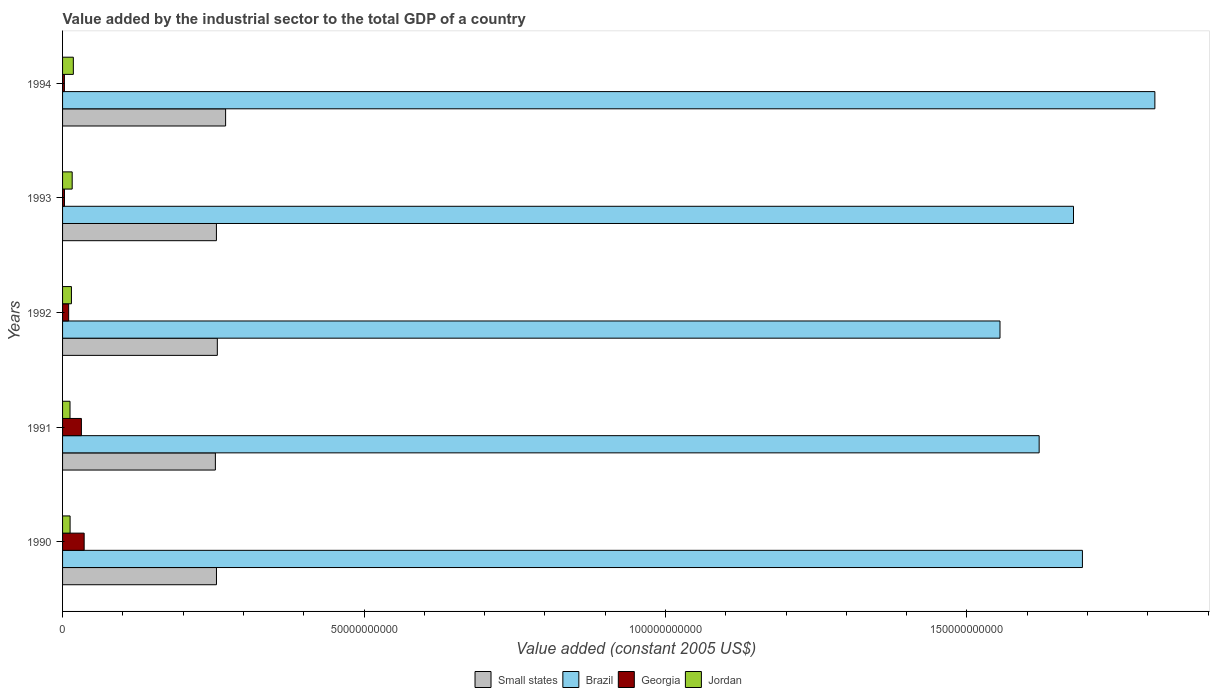How many different coloured bars are there?
Provide a short and direct response. 4. Are the number of bars on each tick of the Y-axis equal?
Keep it short and to the point. Yes. How many bars are there on the 1st tick from the bottom?
Provide a succinct answer. 4. What is the label of the 4th group of bars from the top?
Your response must be concise. 1991. What is the value added by the industrial sector in Georgia in 1992?
Your response must be concise. 1.01e+09. Across all years, what is the maximum value added by the industrial sector in Small states?
Your answer should be very brief. 2.70e+1. Across all years, what is the minimum value added by the industrial sector in Small states?
Provide a succinct answer. 2.53e+1. In which year was the value added by the industrial sector in Small states maximum?
Keep it short and to the point. 1994. What is the total value added by the industrial sector in Brazil in the graph?
Keep it short and to the point. 8.35e+11. What is the difference between the value added by the industrial sector in Jordan in 1990 and that in 1991?
Provide a succinct answer. 1.42e+07. What is the difference between the value added by the industrial sector in Georgia in 1992 and the value added by the industrial sector in Jordan in 1994?
Offer a terse response. -7.79e+08. What is the average value added by the industrial sector in Brazil per year?
Give a very brief answer. 1.67e+11. In the year 1992, what is the difference between the value added by the industrial sector in Jordan and value added by the industrial sector in Brazil?
Your answer should be very brief. -1.54e+11. In how many years, is the value added by the industrial sector in Small states greater than 10000000000 US$?
Give a very brief answer. 5. What is the ratio of the value added by the industrial sector in Small states in 1991 to that in 1992?
Give a very brief answer. 0.99. Is the difference between the value added by the industrial sector in Jordan in 1990 and 1991 greater than the difference between the value added by the industrial sector in Brazil in 1990 and 1991?
Provide a succinct answer. No. What is the difference between the highest and the second highest value added by the industrial sector in Jordan?
Make the answer very short. 1.92e+08. What is the difference between the highest and the lowest value added by the industrial sector in Georgia?
Keep it short and to the point. 3.28e+09. Is the sum of the value added by the industrial sector in Jordan in 1993 and 1994 greater than the maximum value added by the industrial sector in Small states across all years?
Your answer should be very brief. No. Is it the case that in every year, the sum of the value added by the industrial sector in Small states and value added by the industrial sector in Georgia is greater than the sum of value added by the industrial sector in Brazil and value added by the industrial sector in Jordan?
Offer a terse response. No. What does the 2nd bar from the top in 1990 represents?
Provide a succinct answer. Georgia. Is it the case that in every year, the sum of the value added by the industrial sector in Brazil and value added by the industrial sector in Small states is greater than the value added by the industrial sector in Jordan?
Your answer should be compact. Yes. Are all the bars in the graph horizontal?
Keep it short and to the point. Yes. Are the values on the major ticks of X-axis written in scientific E-notation?
Keep it short and to the point. No. Does the graph contain grids?
Keep it short and to the point. No. Where does the legend appear in the graph?
Provide a short and direct response. Bottom center. How many legend labels are there?
Provide a succinct answer. 4. How are the legend labels stacked?
Provide a succinct answer. Horizontal. What is the title of the graph?
Offer a terse response. Value added by the industrial sector to the total GDP of a country. What is the label or title of the X-axis?
Offer a very short reply. Value added (constant 2005 US$). What is the label or title of the Y-axis?
Your response must be concise. Years. What is the Value added (constant 2005 US$) of Small states in 1990?
Give a very brief answer. 2.55e+1. What is the Value added (constant 2005 US$) of Brazil in 1990?
Make the answer very short. 1.69e+11. What is the Value added (constant 2005 US$) of Georgia in 1990?
Your response must be concise. 3.58e+09. What is the Value added (constant 2005 US$) of Jordan in 1990?
Ensure brevity in your answer.  1.25e+09. What is the Value added (constant 2005 US$) in Small states in 1991?
Your response must be concise. 2.53e+1. What is the Value added (constant 2005 US$) of Brazil in 1991?
Provide a short and direct response. 1.62e+11. What is the Value added (constant 2005 US$) in Georgia in 1991?
Provide a short and direct response. 3.12e+09. What is the Value added (constant 2005 US$) in Jordan in 1991?
Keep it short and to the point. 1.23e+09. What is the Value added (constant 2005 US$) of Small states in 1992?
Your answer should be compact. 2.57e+1. What is the Value added (constant 2005 US$) in Brazil in 1992?
Make the answer very short. 1.55e+11. What is the Value added (constant 2005 US$) of Georgia in 1992?
Make the answer very short. 1.01e+09. What is the Value added (constant 2005 US$) of Jordan in 1992?
Offer a terse response. 1.47e+09. What is the Value added (constant 2005 US$) of Small states in 1993?
Ensure brevity in your answer.  2.55e+1. What is the Value added (constant 2005 US$) of Brazil in 1993?
Ensure brevity in your answer.  1.68e+11. What is the Value added (constant 2005 US$) in Georgia in 1993?
Your response must be concise. 3.16e+08. What is the Value added (constant 2005 US$) in Jordan in 1993?
Your response must be concise. 1.60e+09. What is the Value added (constant 2005 US$) of Small states in 1994?
Your response must be concise. 2.70e+1. What is the Value added (constant 2005 US$) of Brazil in 1994?
Make the answer very short. 1.81e+11. What is the Value added (constant 2005 US$) in Georgia in 1994?
Keep it short and to the point. 3.04e+08. What is the Value added (constant 2005 US$) in Jordan in 1994?
Offer a very short reply. 1.79e+09. Across all years, what is the maximum Value added (constant 2005 US$) in Small states?
Offer a terse response. 2.70e+1. Across all years, what is the maximum Value added (constant 2005 US$) of Brazil?
Offer a very short reply. 1.81e+11. Across all years, what is the maximum Value added (constant 2005 US$) of Georgia?
Provide a short and direct response. 3.58e+09. Across all years, what is the maximum Value added (constant 2005 US$) of Jordan?
Your response must be concise. 1.79e+09. Across all years, what is the minimum Value added (constant 2005 US$) of Small states?
Provide a short and direct response. 2.53e+1. Across all years, what is the minimum Value added (constant 2005 US$) of Brazil?
Make the answer very short. 1.55e+11. Across all years, what is the minimum Value added (constant 2005 US$) of Georgia?
Make the answer very short. 3.04e+08. Across all years, what is the minimum Value added (constant 2005 US$) in Jordan?
Offer a very short reply. 1.23e+09. What is the total Value added (constant 2005 US$) of Small states in the graph?
Provide a succinct answer. 1.29e+11. What is the total Value added (constant 2005 US$) of Brazil in the graph?
Keep it short and to the point. 8.35e+11. What is the total Value added (constant 2005 US$) in Georgia in the graph?
Offer a very short reply. 8.33e+09. What is the total Value added (constant 2005 US$) in Jordan in the graph?
Your answer should be very brief. 7.34e+09. What is the difference between the Value added (constant 2005 US$) of Small states in 1990 and that in 1991?
Your response must be concise. 1.81e+08. What is the difference between the Value added (constant 2005 US$) in Brazil in 1990 and that in 1991?
Provide a short and direct response. 7.18e+09. What is the difference between the Value added (constant 2005 US$) in Georgia in 1990 and that in 1991?
Offer a very short reply. 4.58e+08. What is the difference between the Value added (constant 2005 US$) in Jordan in 1990 and that in 1991?
Offer a very short reply. 1.42e+07. What is the difference between the Value added (constant 2005 US$) in Small states in 1990 and that in 1992?
Your response must be concise. -1.41e+08. What is the difference between the Value added (constant 2005 US$) in Brazil in 1990 and that in 1992?
Your response must be concise. 1.37e+1. What is the difference between the Value added (constant 2005 US$) in Georgia in 1990 and that in 1992?
Offer a terse response. 2.57e+09. What is the difference between the Value added (constant 2005 US$) in Jordan in 1990 and that in 1992?
Offer a terse response. -2.22e+08. What is the difference between the Value added (constant 2005 US$) of Small states in 1990 and that in 1993?
Offer a terse response. 9.01e+06. What is the difference between the Value added (constant 2005 US$) in Brazil in 1990 and that in 1993?
Your answer should be compact. 1.48e+09. What is the difference between the Value added (constant 2005 US$) of Georgia in 1990 and that in 1993?
Provide a succinct answer. 3.27e+09. What is the difference between the Value added (constant 2005 US$) in Jordan in 1990 and that in 1993?
Your answer should be compact. -3.48e+08. What is the difference between the Value added (constant 2005 US$) in Small states in 1990 and that in 1994?
Your answer should be very brief. -1.52e+09. What is the difference between the Value added (constant 2005 US$) in Brazil in 1990 and that in 1994?
Your answer should be very brief. -1.20e+1. What is the difference between the Value added (constant 2005 US$) in Georgia in 1990 and that in 1994?
Your response must be concise. 3.28e+09. What is the difference between the Value added (constant 2005 US$) in Jordan in 1990 and that in 1994?
Offer a very short reply. -5.40e+08. What is the difference between the Value added (constant 2005 US$) in Small states in 1991 and that in 1992?
Give a very brief answer. -3.23e+08. What is the difference between the Value added (constant 2005 US$) in Brazil in 1991 and that in 1992?
Offer a very short reply. 6.49e+09. What is the difference between the Value added (constant 2005 US$) of Georgia in 1991 and that in 1992?
Your response must be concise. 2.11e+09. What is the difference between the Value added (constant 2005 US$) in Jordan in 1991 and that in 1992?
Your answer should be compact. -2.37e+08. What is the difference between the Value added (constant 2005 US$) of Small states in 1991 and that in 1993?
Provide a short and direct response. -1.72e+08. What is the difference between the Value added (constant 2005 US$) in Brazil in 1991 and that in 1993?
Offer a terse response. -5.70e+09. What is the difference between the Value added (constant 2005 US$) of Georgia in 1991 and that in 1993?
Offer a terse response. 2.81e+09. What is the difference between the Value added (constant 2005 US$) of Jordan in 1991 and that in 1993?
Offer a terse response. -3.62e+08. What is the difference between the Value added (constant 2005 US$) of Small states in 1991 and that in 1994?
Ensure brevity in your answer.  -1.70e+09. What is the difference between the Value added (constant 2005 US$) in Brazil in 1991 and that in 1994?
Give a very brief answer. -1.92e+1. What is the difference between the Value added (constant 2005 US$) of Georgia in 1991 and that in 1994?
Give a very brief answer. 2.82e+09. What is the difference between the Value added (constant 2005 US$) in Jordan in 1991 and that in 1994?
Offer a terse response. -5.54e+08. What is the difference between the Value added (constant 2005 US$) of Small states in 1992 and that in 1993?
Keep it short and to the point. 1.50e+08. What is the difference between the Value added (constant 2005 US$) in Brazil in 1992 and that in 1993?
Ensure brevity in your answer.  -1.22e+1. What is the difference between the Value added (constant 2005 US$) in Georgia in 1992 and that in 1993?
Your response must be concise. 6.94e+08. What is the difference between the Value added (constant 2005 US$) of Jordan in 1992 and that in 1993?
Provide a short and direct response. -1.25e+08. What is the difference between the Value added (constant 2005 US$) in Small states in 1992 and that in 1994?
Your answer should be very brief. -1.37e+09. What is the difference between the Value added (constant 2005 US$) of Brazil in 1992 and that in 1994?
Your response must be concise. -2.57e+1. What is the difference between the Value added (constant 2005 US$) in Georgia in 1992 and that in 1994?
Offer a terse response. 7.05e+08. What is the difference between the Value added (constant 2005 US$) of Jordan in 1992 and that in 1994?
Ensure brevity in your answer.  -3.17e+08. What is the difference between the Value added (constant 2005 US$) of Small states in 1993 and that in 1994?
Offer a very short reply. -1.52e+09. What is the difference between the Value added (constant 2005 US$) in Brazil in 1993 and that in 1994?
Provide a succinct answer. -1.35e+1. What is the difference between the Value added (constant 2005 US$) in Georgia in 1993 and that in 1994?
Your answer should be very brief. 1.17e+07. What is the difference between the Value added (constant 2005 US$) in Jordan in 1993 and that in 1994?
Offer a very short reply. -1.92e+08. What is the difference between the Value added (constant 2005 US$) in Small states in 1990 and the Value added (constant 2005 US$) in Brazil in 1991?
Offer a very short reply. -1.36e+11. What is the difference between the Value added (constant 2005 US$) of Small states in 1990 and the Value added (constant 2005 US$) of Georgia in 1991?
Your answer should be very brief. 2.24e+1. What is the difference between the Value added (constant 2005 US$) in Small states in 1990 and the Value added (constant 2005 US$) in Jordan in 1991?
Your answer should be very brief. 2.43e+1. What is the difference between the Value added (constant 2005 US$) of Brazil in 1990 and the Value added (constant 2005 US$) of Georgia in 1991?
Offer a terse response. 1.66e+11. What is the difference between the Value added (constant 2005 US$) in Brazil in 1990 and the Value added (constant 2005 US$) in Jordan in 1991?
Your answer should be very brief. 1.68e+11. What is the difference between the Value added (constant 2005 US$) in Georgia in 1990 and the Value added (constant 2005 US$) in Jordan in 1991?
Keep it short and to the point. 2.35e+09. What is the difference between the Value added (constant 2005 US$) of Small states in 1990 and the Value added (constant 2005 US$) of Brazil in 1992?
Ensure brevity in your answer.  -1.30e+11. What is the difference between the Value added (constant 2005 US$) of Small states in 1990 and the Value added (constant 2005 US$) of Georgia in 1992?
Provide a succinct answer. 2.45e+1. What is the difference between the Value added (constant 2005 US$) in Small states in 1990 and the Value added (constant 2005 US$) in Jordan in 1992?
Your response must be concise. 2.41e+1. What is the difference between the Value added (constant 2005 US$) in Brazil in 1990 and the Value added (constant 2005 US$) in Georgia in 1992?
Offer a very short reply. 1.68e+11. What is the difference between the Value added (constant 2005 US$) of Brazil in 1990 and the Value added (constant 2005 US$) of Jordan in 1992?
Make the answer very short. 1.68e+11. What is the difference between the Value added (constant 2005 US$) of Georgia in 1990 and the Value added (constant 2005 US$) of Jordan in 1992?
Your answer should be compact. 2.11e+09. What is the difference between the Value added (constant 2005 US$) of Small states in 1990 and the Value added (constant 2005 US$) of Brazil in 1993?
Provide a succinct answer. -1.42e+11. What is the difference between the Value added (constant 2005 US$) of Small states in 1990 and the Value added (constant 2005 US$) of Georgia in 1993?
Provide a short and direct response. 2.52e+1. What is the difference between the Value added (constant 2005 US$) of Small states in 1990 and the Value added (constant 2005 US$) of Jordan in 1993?
Give a very brief answer. 2.39e+1. What is the difference between the Value added (constant 2005 US$) in Brazil in 1990 and the Value added (constant 2005 US$) in Georgia in 1993?
Offer a very short reply. 1.69e+11. What is the difference between the Value added (constant 2005 US$) in Brazil in 1990 and the Value added (constant 2005 US$) in Jordan in 1993?
Give a very brief answer. 1.68e+11. What is the difference between the Value added (constant 2005 US$) in Georgia in 1990 and the Value added (constant 2005 US$) in Jordan in 1993?
Provide a short and direct response. 1.99e+09. What is the difference between the Value added (constant 2005 US$) of Small states in 1990 and the Value added (constant 2005 US$) of Brazil in 1994?
Offer a very short reply. -1.56e+11. What is the difference between the Value added (constant 2005 US$) in Small states in 1990 and the Value added (constant 2005 US$) in Georgia in 1994?
Provide a short and direct response. 2.52e+1. What is the difference between the Value added (constant 2005 US$) of Small states in 1990 and the Value added (constant 2005 US$) of Jordan in 1994?
Give a very brief answer. 2.37e+1. What is the difference between the Value added (constant 2005 US$) in Brazil in 1990 and the Value added (constant 2005 US$) in Georgia in 1994?
Your answer should be compact. 1.69e+11. What is the difference between the Value added (constant 2005 US$) in Brazil in 1990 and the Value added (constant 2005 US$) in Jordan in 1994?
Provide a succinct answer. 1.67e+11. What is the difference between the Value added (constant 2005 US$) in Georgia in 1990 and the Value added (constant 2005 US$) in Jordan in 1994?
Ensure brevity in your answer.  1.79e+09. What is the difference between the Value added (constant 2005 US$) of Small states in 1991 and the Value added (constant 2005 US$) of Brazil in 1992?
Keep it short and to the point. -1.30e+11. What is the difference between the Value added (constant 2005 US$) of Small states in 1991 and the Value added (constant 2005 US$) of Georgia in 1992?
Make the answer very short. 2.43e+1. What is the difference between the Value added (constant 2005 US$) of Small states in 1991 and the Value added (constant 2005 US$) of Jordan in 1992?
Offer a very short reply. 2.39e+1. What is the difference between the Value added (constant 2005 US$) in Brazil in 1991 and the Value added (constant 2005 US$) in Georgia in 1992?
Provide a short and direct response. 1.61e+11. What is the difference between the Value added (constant 2005 US$) of Brazil in 1991 and the Value added (constant 2005 US$) of Jordan in 1992?
Offer a terse response. 1.61e+11. What is the difference between the Value added (constant 2005 US$) of Georgia in 1991 and the Value added (constant 2005 US$) of Jordan in 1992?
Give a very brief answer. 1.65e+09. What is the difference between the Value added (constant 2005 US$) in Small states in 1991 and the Value added (constant 2005 US$) in Brazil in 1993?
Give a very brief answer. -1.42e+11. What is the difference between the Value added (constant 2005 US$) in Small states in 1991 and the Value added (constant 2005 US$) in Georgia in 1993?
Offer a terse response. 2.50e+1. What is the difference between the Value added (constant 2005 US$) in Small states in 1991 and the Value added (constant 2005 US$) in Jordan in 1993?
Provide a short and direct response. 2.37e+1. What is the difference between the Value added (constant 2005 US$) in Brazil in 1991 and the Value added (constant 2005 US$) in Georgia in 1993?
Ensure brevity in your answer.  1.62e+11. What is the difference between the Value added (constant 2005 US$) in Brazil in 1991 and the Value added (constant 2005 US$) in Jordan in 1993?
Make the answer very short. 1.60e+11. What is the difference between the Value added (constant 2005 US$) of Georgia in 1991 and the Value added (constant 2005 US$) of Jordan in 1993?
Make the answer very short. 1.53e+09. What is the difference between the Value added (constant 2005 US$) of Small states in 1991 and the Value added (constant 2005 US$) of Brazil in 1994?
Your response must be concise. -1.56e+11. What is the difference between the Value added (constant 2005 US$) of Small states in 1991 and the Value added (constant 2005 US$) of Georgia in 1994?
Your answer should be compact. 2.50e+1. What is the difference between the Value added (constant 2005 US$) in Small states in 1991 and the Value added (constant 2005 US$) in Jordan in 1994?
Provide a short and direct response. 2.36e+1. What is the difference between the Value added (constant 2005 US$) in Brazil in 1991 and the Value added (constant 2005 US$) in Georgia in 1994?
Keep it short and to the point. 1.62e+11. What is the difference between the Value added (constant 2005 US$) in Brazil in 1991 and the Value added (constant 2005 US$) in Jordan in 1994?
Ensure brevity in your answer.  1.60e+11. What is the difference between the Value added (constant 2005 US$) in Georgia in 1991 and the Value added (constant 2005 US$) in Jordan in 1994?
Keep it short and to the point. 1.34e+09. What is the difference between the Value added (constant 2005 US$) of Small states in 1992 and the Value added (constant 2005 US$) of Brazil in 1993?
Your answer should be compact. -1.42e+11. What is the difference between the Value added (constant 2005 US$) in Small states in 1992 and the Value added (constant 2005 US$) in Georgia in 1993?
Your response must be concise. 2.54e+1. What is the difference between the Value added (constant 2005 US$) of Small states in 1992 and the Value added (constant 2005 US$) of Jordan in 1993?
Provide a short and direct response. 2.41e+1. What is the difference between the Value added (constant 2005 US$) of Brazil in 1992 and the Value added (constant 2005 US$) of Georgia in 1993?
Make the answer very short. 1.55e+11. What is the difference between the Value added (constant 2005 US$) in Brazil in 1992 and the Value added (constant 2005 US$) in Jordan in 1993?
Ensure brevity in your answer.  1.54e+11. What is the difference between the Value added (constant 2005 US$) of Georgia in 1992 and the Value added (constant 2005 US$) of Jordan in 1993?
Keep it short and to the point. -5.87e+08. What is the difference between the Value added (constant 2005 US$) of Small states in 1992 and the Value added (constant 2005 US$) of Brazil in 1994?
Provide a short and direct response. -1.56e+11. What is the difference between the Value added (constant 2005 US$) in Small states in 1992 and the Value added (constant 2005 US$) in Georgia in 1994?
Make the answer very short. 2.54e+1. What is the difference between the Value added (constant 2005 US$) in Small states in 1992 and the Value added (constant 2005 US$) in Jordan in 1994?
Provide a succinct answer. 2.39e+1. What is the difference between the Value added (constant 2005 US$) of Brazil in 1992 and the Value added (constant 2005 US$) of Georgia in 1994?
Provide a short and direct response. 1.55e+11. What is the difference between the Value added (constant 2005 US$) of Brazil in 1992 and the Value added (constant 2005 US$) of Jordan in 1994?
Give a very brief answer. 1.54e+11. What is the difference between the Value added (constant 2005 US$) in Georgia in 1992 and the Value added (constant 2005 US$) in Jordan in 1994?
Offer a terse response. -7.79e+08. What is the difference between the Value added (constant 2005 US$) of Small states in 1993 and the Value added (constant 2005 US$) of Brazil in 1994?
Your response must be concise. -1.56e+11. What is the difference between the Value added (constant 2005 US$) in Small states in 1993 and the Value added (constant 2005 US$) in Georgia in 1994?
Your response must be concise. 2.52e+1. What is the difference between the Value added (constant 2005 US$) of Small states in 1993 and the Value added (constant 2005 US$) of Jordan in 1994?
Keep it short and to the point. 2.37e+1. What is the difference between the Value added (constant 2005 US$) in Brazil in 1993 and the Value added (constant 2005 US$) in Georgia in 1994?
Provide a succinct answer. 1.67e+11. What is the difference between the Value added (constant 2005 US$) of Brazil in 1993 and the Value added (constant 2005 US$) of Jordan in 1994?
Offer a very short reply. 1.66e+11. What is the difference between the Value added (constant 2005 US$) in Georgia in 1993 and the Value added (constant 2005 US$) in Jordan in 1994?
Offer a very short reply. -1.47e+09. What is the average Value added (constant 2005 US$) of Small states per year?
Provide a succinct answer. 2.58e+1. What is the average Value added (constant 2005 US$) of Brazil per year?
Offer a very short reply. 1.67e+11. What is the average Value added (constant 2005 US$) in Georgia per year?
Make the answer very short. 1.67e+09. What is the average Value added (constant 2005 US$) in Jordan per year?
Keep it short and to the point. 1.47e+09. In the year 1990, what is the difference between the Value added (constant 2005 US$) of Small states and Value added (constant 2005 US$) of Brazil?
Your answer should be very brief. -1.44e+11. In the year 1990, what is the difference between the Value added (constant 2005 US$) of Small states and Value added (constant 2005 US$) of Georgia?
Give a very brief answer. 2.19e+1. In the year 1990, what is the difference between the Value added (constant 2005 US$) of Small states and Value added (constant 2005 US$) of Jordan?
Ensure brevity in your answer.  2.43e+1. In the year 1990, what is the difference between the Value added (constant 2005 US$) in Brazil and Value added (constant 2005 US$) in Georgia?
Your answer should be compact. 1.66e+11. In the year 1990, what is the difference between the Value added (constant 2005 US$) of Brazil and Value added (constant 2005 US$) of Jordan?
Keep it short and to the point. 1.68e+11. In the year 1990, what is the difference between the Value added (constant 2005 US$) in Georgia and Value added (constant 2005 US$) in Jordan?
Offer a terse response. 2.33e+09. In the year 1991, what is the difference between the Value added (constant 2005 US$) in Small states and Value added (constant 2005 US$) in Brazil?
Give a very brief answer. -1.37e+11. In the year 1991, what is the difference between the Value added (constant 2005 US$) of Small states and Value added (constant 2005 US$) of Georgia?
Give a very brief answer. 2.22e+1. In the year 1991, what is the difference between the Value added (constant 2005 US$) of Small states and Value added (constant 2005 US$) of Jordan?
Ensure brevity in your answer.  2.41e+1. In the year 1991, what is the difference between the Value added (constant 2005 US$) of Brazil and Value added (constant 2005 US$) of Georgia?
Keep it short and to the point. 1.59e+11. In the year 1991, what is the difference between the Value added (constant 2005 US$) of Brazil and Value added (constant 2005 US$) of Jordan?
Your response must be concise. 1.61e+11. In the year 1991, what is the difference between the Value added (constant 2005 US$) in Georgia and Value added (constant 2005 US$) in Jordan?
Provide a succinct answer. 1.89e+09. In the year 1992, what is the difference between the Value added (constant 2005 US$) in Small states and Value added (constant 2005 US$) in Brazil?
Ensure brevity in your answer.  -1.30e+11. In the year 1992, what is the difference between the Value added (constant 2005 US$) in Small states and Value added (constant 2005 US$) in Georgia?
Provide a succinct answer. 2.47e+1. In the year 1992, what is the difference between the Value added (constant 2005 US$) of Small states and Value added (constant 2005 US$) of Jordan?
Your answer should be compact. 2.42e+1. In the year 1992, what is the difference between the Value added (constant 2005 US$) in Brazil and Value added (constant 2005 US$) in Georgia?
Your answer should be compact. 1.54e+11. In the year 1992, what is the difference between the Value added (constant 2005 US$) in Brazil and Value added (constant 2005 US$) in Jordan?
Give a very brief answer. 1.54e+11. In the year 1992, what is the difference between the Value added (constant 2005 US$) of Georgia and Value added (constant 2005 US$) of Jordan?
Keep it short and to the point. -4.61e+08. In the year 1993, what is the difference between the Value added (constant 2005 US$) of Small states and Value added (constant 2005 US$) of Brazil?
Your response must be concise. -1.42e+11. In the year 1993, what is the difference between the Value added (constant 2005 US$) of Small states and Value added (constant 2005 US$) of Georgia?
Make the answer very short. 2.52e+1. In the year 1993, what is the difference between the Value added (constant 2005 US$) of Small states and Value added (constant 2005 US$) of Jordan?
Keep it short and to the point. 2.39e+1. In the year 1993, what is the difference between the Value added (constant 2005 US$) of Brazil and Value added (constant 2005 US$) of Georgia?
Provide a succinct answer. 1.67e+11. In the year 1993, what is the difference between the Value added (constant 2005 US$) of Brazil and Value added (constant 2005 US$) of Jordan?
Make the answer very short. 1.66e+11. In the year 1993, what is the difference between the Value added (constant 2005 US$) in Georgia and Value added (constant 2005 US$) in Jordan?
Provide a short and direct response. -1.28e+09. In the year 1994, what is the difference between the Value added (constant 2005 US$) of Small states and Value added (constant 2005 US$) of Brazil?
Give a very brief answer. -1.54e+11. In the year 1994, what is the difference between the Value added (constant 2005 US$) in Small states and Value added (constant 2005 US$) in Georgia?
Keep it short and to the point. 2.67e+1. In the year 1994, what is the difference between the Value added (constant 2005 US$) of Small states and Value added (constant 2005 US$) of Jordan?
Ensure brevity in your answer.  2.53e+1. In the year 1994, what is the difference between the Value added (constant 2005 US$) in Brazil and Value added (constant 2005 US$) in Georgia?
Your response must be concise. 1.81e+11. In the year 1994, what is the difference between the Value added (constant 2005 US$) of Brazil and Value added (constant 2005 US$) of Jordan?
Ensure brevity in your answer.  1.79e+11. In the year 1994, what is the difference between the Value added (constant 2005 US$) of Georgia and Value added (constant 2005 US$) of Jordan?
Your response must be concise. -1.48e+09. What is the ratio of the Value added (constant 2005 US$) in Small states in 1990 to that in 1991?
Your response must be concise. 1.01. What is the ratio of the Value added (constant 2005 US$) of Brazil in 1990 to that in 1991?
Make the answer very short. 1.04. What is the ratio of the Value added (constant 2005 US$) of Georgia in 1990 to that in 1991?
Make the answer very short. 1.15. What is the ratio of the Value added (constant 2005 US$) in Jordan in 1990 to that in 1991?
Your answer should be compact. 1.01. What is the ratio of the Value added (constant 2005 US$) of Small states in 1990 to that in 1992?
Provide a short and direct response. 0.99. What is the ratio of the Value added (constant 2005 US$) in Brazil in 1990 to that in 1992?
Your answer should be very brief. 1.09. What is the ratio of the Value added (constant 2005 US$) of Georgia in 1990 to that in 1992?
Your response must be concise. 3.55. What is the ratio of the Value added (constant 2005 US$) of Jordan in 1990 to that in 1992?
Keep it short and to the point. 0.85. What is the ratio of the Value added (constant 2005 US$) of Brazil in 1990 to that in 1993?
Offer a very short reply. 1.01. What is the ratio of the Value added (constant 2005 US$) of Georgia in 1990 to that in 1993?
Offer a terse response. 11.34. What is the ratio of the Value added (constant 2005 US$) of Jordan in 1990 to that in 1993?
Your answer should be compact. 0.78. What is the ratio of the Value added (constant 2005 US$) of Small states in 1990 to that in 1994?
Offer a very short reply. 0.94. What is the ratio of the Value added (constant 2005 US$) of Brazil in 1990 to that in 1994?
Your response must be concise. 0.93. What is the ratio of the Value added (constant 2005 US$) of Georgia in 1990 to that in 1994?
Give a very brief answer. 11.78. What is the ratio of the Value added (constant 2005 US$) in Jordan in 1990 to that in 1994?
Your answer should be very brief. 0.7. What is the ratio of the Value added (constant 2005 US$) in Small states in 1991 to that in 1992?
Keep it short and to the point. 0.99. What is the ratio of the Value added (constant 2005 US$) of Brazil in 1991 to that in 1992?
Your answer should be compact. 1.04. What is the ratio of the Value added (constant 2005 US$) in Georgia in 1991 to that in 1992?
Your answer should be very brief. 3.09. What is the ratio of the Value added (constant 2005 US$) in Jordan in 1991 to that in 1992?
Your answer should be very brief. 0.84. What is the ratio of the Value added (constant 2005 US$) of Brazil in 1991 to that in 1993?
Your response must be concise. 0.97. What is the ratio of the Value added (constant 2005 US$) of Georgia in 1991 to that in 1993?
Your response must be concise. 9.89. What is the ratio of the Value added (constant 2005 US$) in Jordan in 1991 to that in 1993?
Offer a very short reply. 0.77. What is the ratio of the Value added (constant 2005 US$) of Small states in 1991 to that in 1994?
Ensure brevity in your answer.  0.94. What is the ratio of the Value added (constant 2005 US$) of Brazil in 1991 to that in 1994?
Make the answer very short. 0.89. What is the ratio of the Value added (constant 2005 US$) in Georgia in 1991 to that in 1994?
Give a very brief answer. 10.27. What is the ratio of the Value added (constant 2005 US$) in Jordan in 1991 to that in 1994?
Offer a terse response. 0.69. What is the ratio of the Value added (constant 2005 US$) in Small states in 1992 to that in 1993?
Offer a terse response. 1.01. What is the ratio of the Value added (constant 2005 US$) in Brazil in 1992 to that in 1993?
Give a very brief answer. 0.93. What is the ratio of the Value added (constant 2005 US$) in Georgia in 1992 to that in 1993?
Keep it short and to the point. 3.2. What is the ratio of the Value added (constant 2005 US$) of Jordan in 1992 to that in 1993?
Your response must be concise. 0.92. What is the ratio of the Value added (constant 2005 US$) in Small states in 1992 to that in 1994?
Provide a short and direct response. 0.95. What is the ratio of the Value added (constant 2005 US$) in Brazil in 1992 to that in 1994?
Provide a succinct answer. 0.86. What is the ratio of the Value added (constant 2005 US$) in Georgia in 1992 to that in 1994?
Ensure brevity in your answer.  3.32. What is the ratio of the Value added (constant 2005 US$) of Jordan in 1992 to that in 1994?
Make the answer very short. 0.82. What is the ratio of the Value added (constant 2005 US$) in Small states in 1993 to that in 1994?
Make the answer very short. 0.94. What is the ratio of the Value added (constant 2005 US$) of Brazil in 1993 to that in 1994?
Your answer should be very brief. 0.93. What is the ratio of the Value added (constant 2005 US$) in Jordan in 1993 to that in 1994?
Provide a short and direct response. 0.89. What is the difference between the highest and the second highest Value added (constant 2005 US$) in Small states?
Provide a short and direct response. 1.37e+09. What is the difference between the highest and the second highest Value added (constant 2005 US$) in Brazil?
Give a very brief answer. 1.20e+1. What is the difference between the highest and the second highest Value added (constant 2005 US$) in Georgia?
Keep it short and to the point. 4.58e+08. What is the difference between the highest and the second highest Value added (constant 2005 US$) in Jordan?
Make the answer very short. 1.92e+08. What is the difference between the highest and the lowest Value added (constant 2005 US$) in Small states?
Ensure brevity in your answer.  1.70e+09. What is the difference between the highest and the lowest Value added (constant 2005 US$) in Brazil?
Ensure brevity in your answer.  2.57e+1. What is the difference between the highest and the lowest Value added (constant 2005 US$) of Georgia?
Provide a short and direct response. 3.28e+09. What is the difference between the highest and the lowest Value added (constant 2005 US$) of Jordan?
Give a very brief answer. 5.54e+08. 